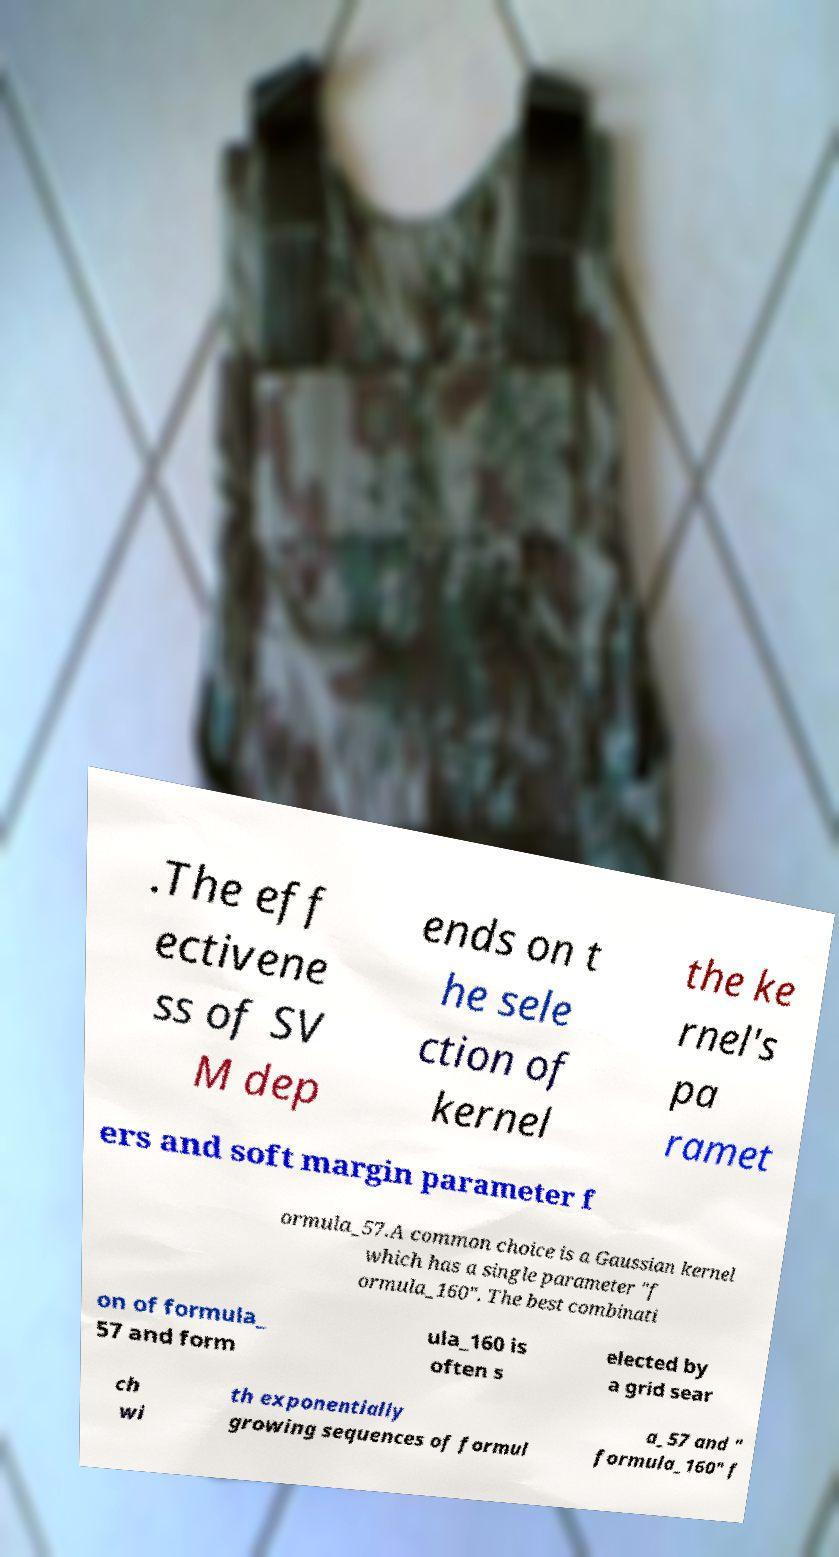Please identify and transcribe the text found in this image. .The eff ectivene ss of SV M dep ends on t he sele ction of kernel the ke rnel's pa ramet ers and soft margin parameter f ormula_57.A common choice is a Gaussian kernel which has a single parameter "f ormula_160". The best combinati on of formula_ 57 and form ula_160 is often s elected by a grid sear ch wi th exponentially growing sequences of formul a_57 and " formula_160" f 